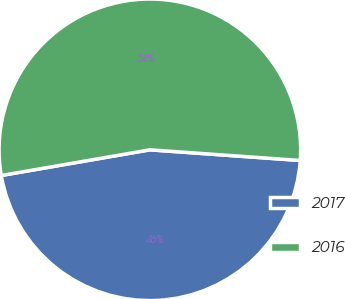<chart> <loc_0><loc_0><loc_500><loc_500><pie_chart><fcel>2017<fcel>2016<nl><fcel>46.15%<fcel>53.85%<nl></chart> 